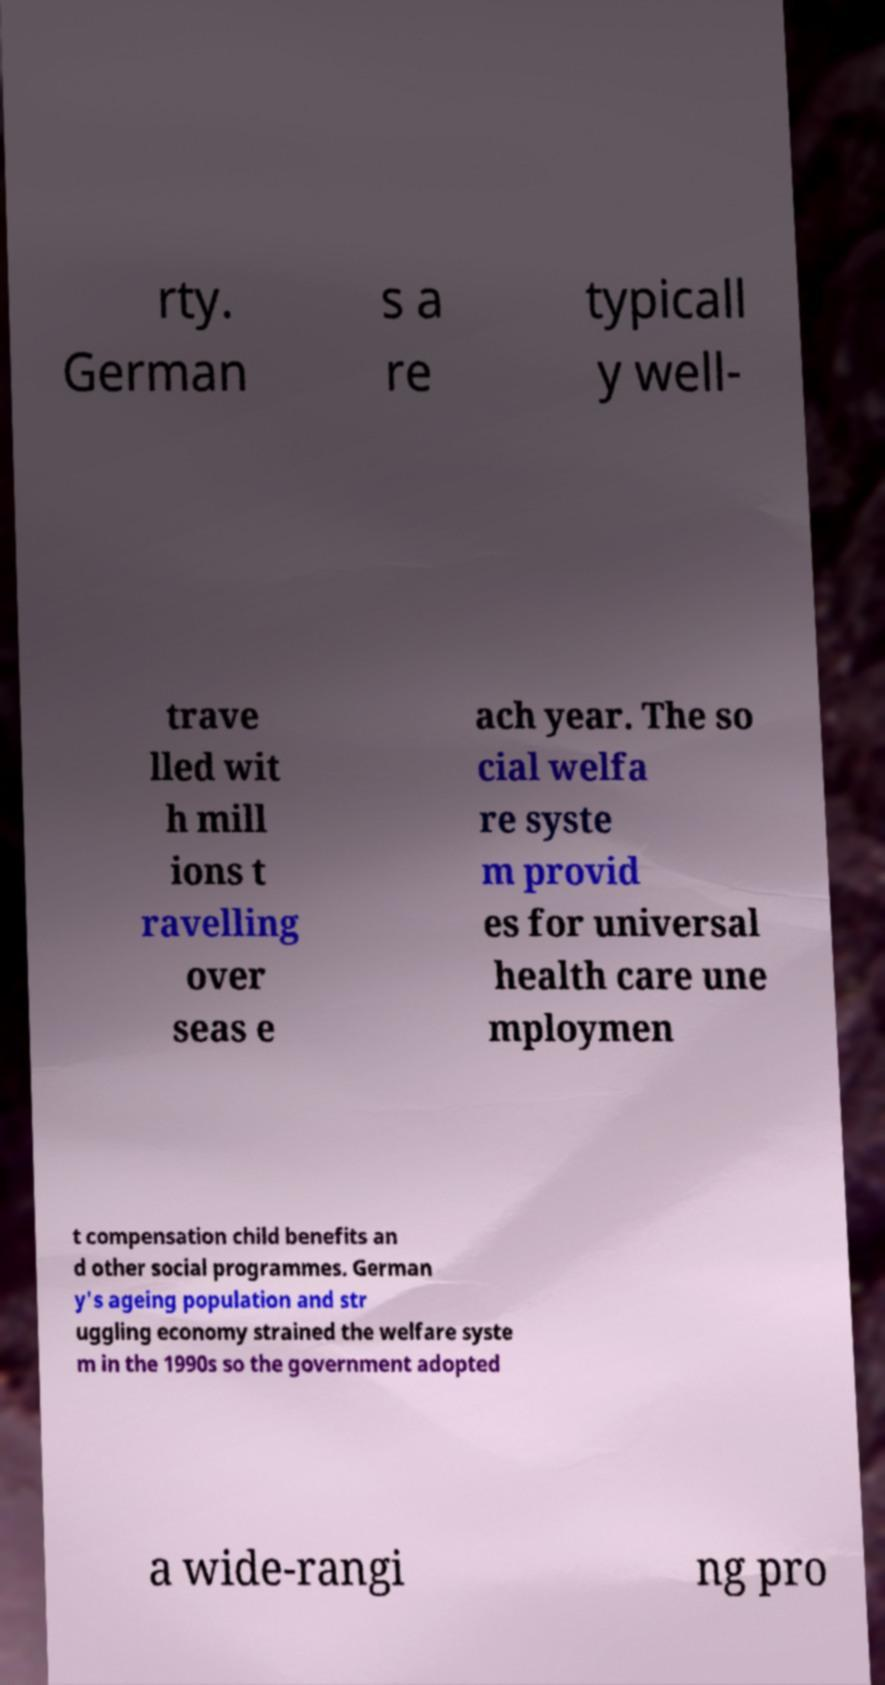Can you read and provide the text displayed in the image?This photo seems to have some interesting text. Can you extract and type it out for me? rty. German s a re typicall y well- trave lled wit h mill ions t ravelling over seas e ach year. The so cial welfa re syste m provid es for universal health care une mploymen t compensation child benefits an d other social programmes. German y's ageing population and str uggling economy strained the welfare syste m in the 1990s so the government adopted a wide-rangi ng pro 